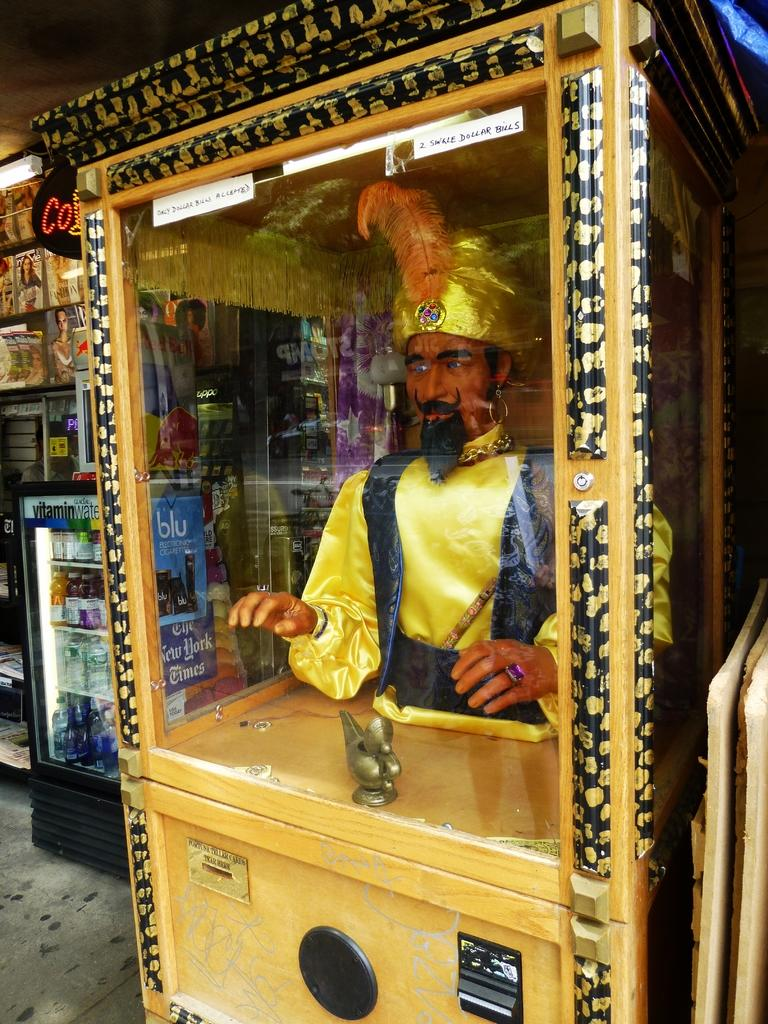What is inside the box in the image? There is a statue in a box in the image. What can be found on the left side of the image? There are books, lights, and a refrigerator on the left side of the image. What is inside the refrigerator? There are bottles inside the refrigerator. What page of the book is the town mentioned on in the image? There are no books open in the image, and no mention of a town, so it is impossible to determine which page the town might be mentioned on. 